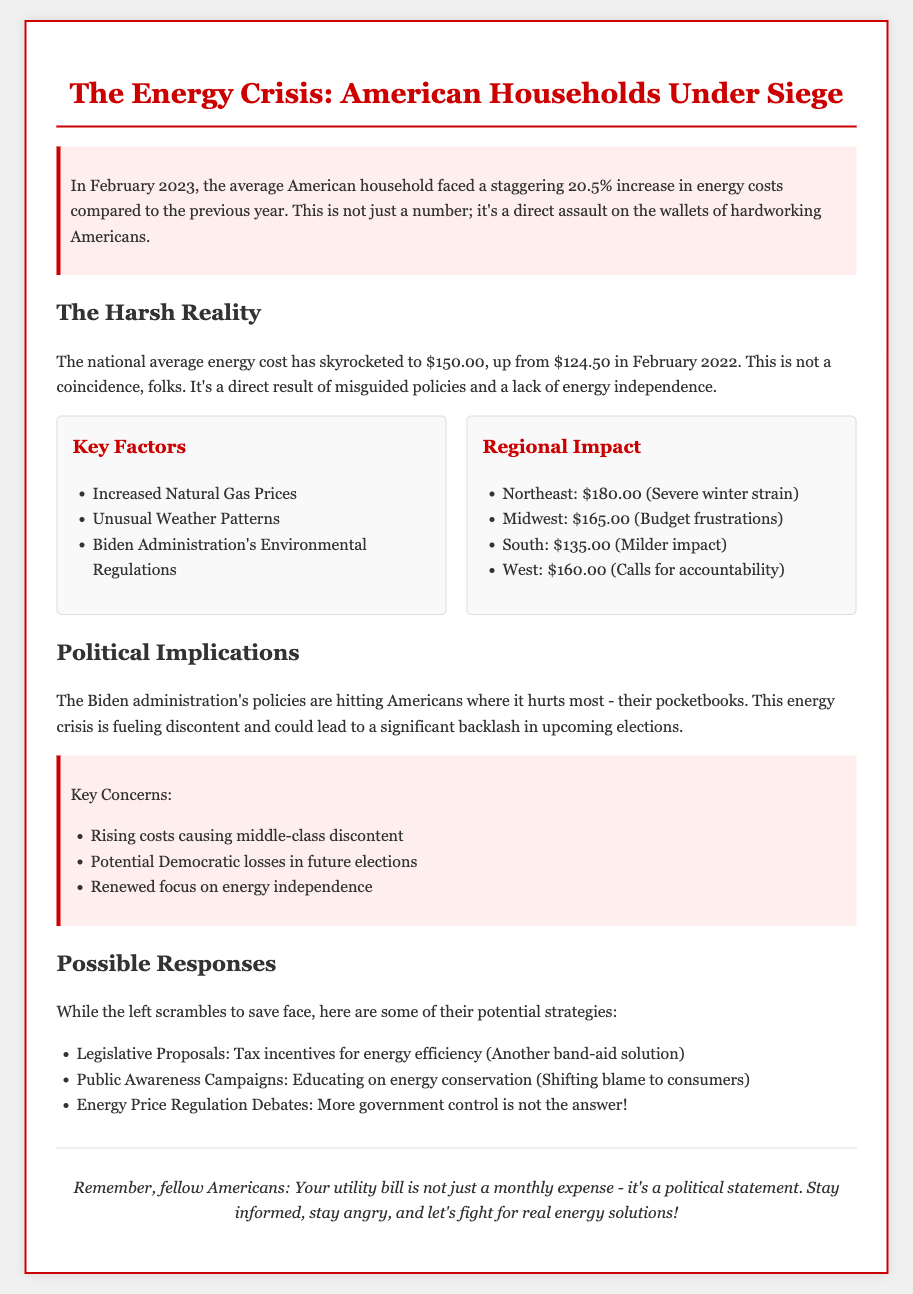What was the average increase in energy costs for February 2023? The document states that the average American household faced a 20.5% increase in energy costs compared to the previous year.
Answer: 20.5% What was the national average energy cost in February 2023? The document indicates that the national average energy cost has risen to $150.00 in February 2023.
Answer: $150.00 What were the energy costs for the Northeast region in February 2023? The document lists the energy cost for the Northeast as $180.00, indicating severe winter strain.
Answer: $180.00 Which administration's policies are blamed for rising energy costs? The document attributes the rising energy costs to the Biden Administration's environmental regulations.
Answer: Biden Administration What are two key concerns mentioned regarding political implications? The document highlights rising costs causing middle-class discontent and potential Democratic losses in future elections as key concerns.
Answer: Rising costs causing middle-class discontent, Potential Democratic losses What strategies are the left likely to adopt in response to the energy crisis? The document mentions tax incentives for energy efficiency and public awareness campaigns as potential strategies the left might use.
Answer: Tax incentives for energy efficiency, Public awareness campaigns How much did the national average energy cost increase from February 2022 to February 2023? The increase can be calculated by comparing the national averages, which went from $124.50 to $150.00.
Answer: $25.50 What does the document suggest about energy independence? The document indicates that the lack of energy independence is a factor contributing to the current energy crisis.
Answer: Lack of energy independence 